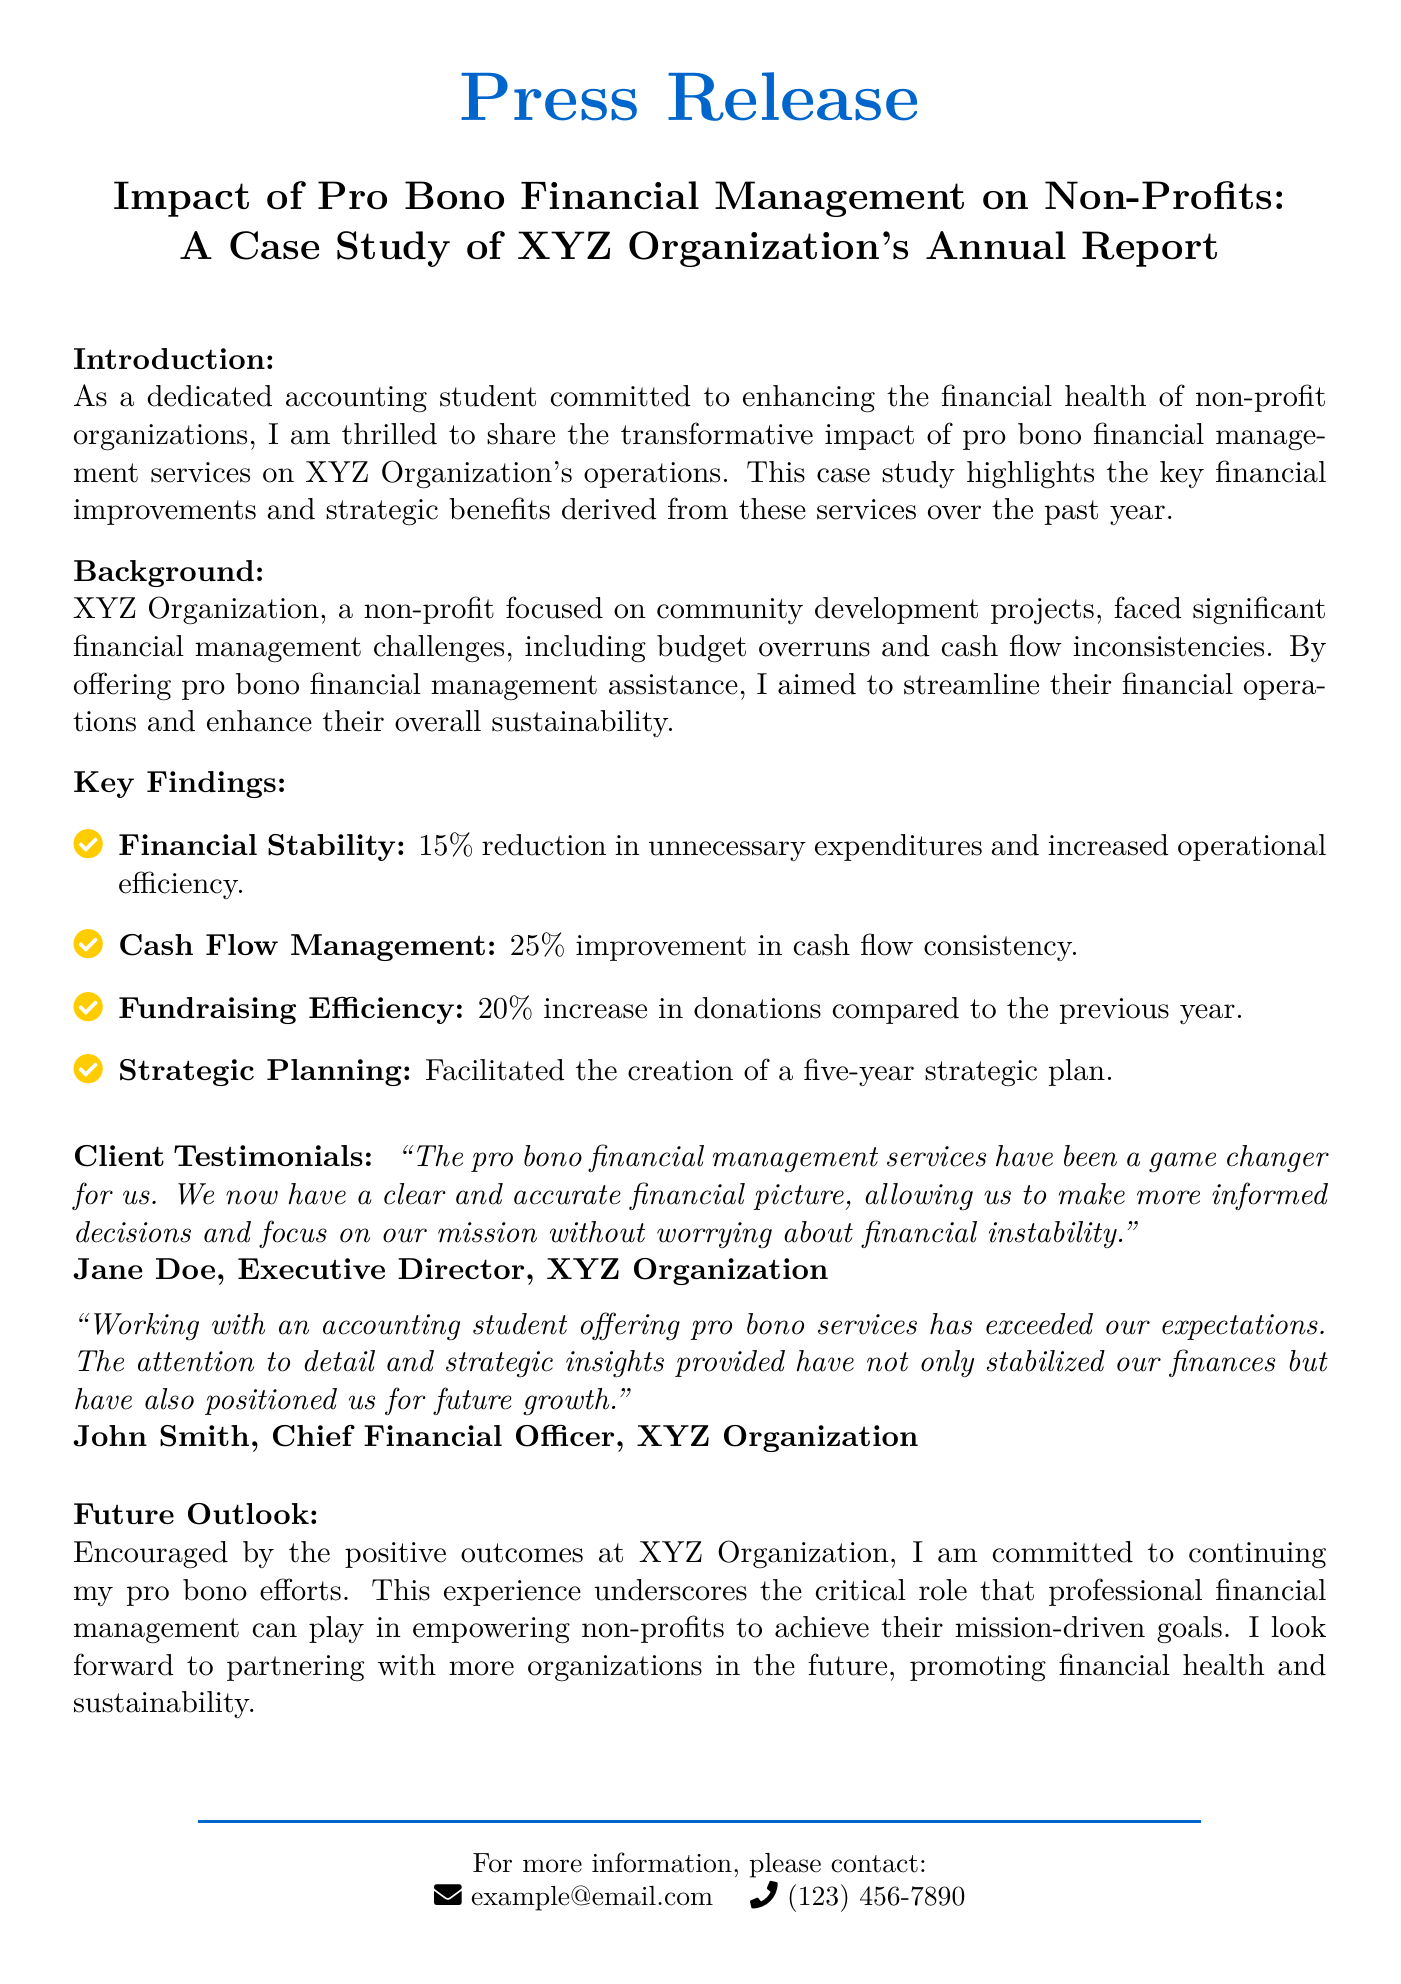What was the percentage reduction in unnecessary expenditures? The document states that there was a 15% reduction in unnecessary expenditures, indicating a financial improvement for XYZ Organization.
Answer: 15% How much did cash flow consistency improve? According to the document, there was a 25% improvement in cash flow consistency as a result of the financial management services.
Answer: 25% What was the increase in donations compared to the previous year? The press release mentions a 20% increase in donations, showcasing the fundraising efficiency achieved through the financial assistance.
Answer: 20% Who is the Executive Director of XYZ Organization? The document cites Jane Doe as the Executive Director, highlighting her perspective on the impact of the pro bono services.
Answer: Jane Doe What is the purpose of XYZ Organization? The press release describes XYZ Organization as focused on community development projects, which establishes its mission.
Answer: community development projects What is a key strategic outcome of the financial management services? The document notes that the facilitation of a five-year strategic plan was a significant outcome of the assistance provided.
Answer: five-year strategic plan What type of services were provided to XYZ Organization? The press release specifically refers to pro bono financial management services that addressed financial challenges faced by the organization.
Answer: pro bono financial management services What is the contact email provided in the press release? The document includes an example email address for inquiries, providing a means of contact for more information.
Answer: example@email.com 